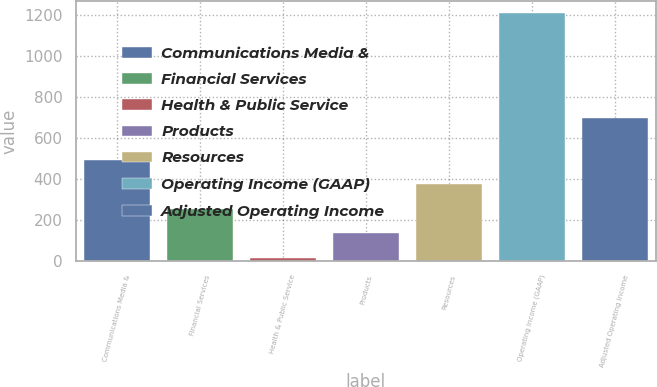Convert chart to OTSL. <chart><loc_0><loc_0><loc_500><loc_500><bar_chart><fcel>Communications Media &<fcel>Financial Services<fcel>Health & Public Service<fcel>Products<fcel>Resources<fcel>Operating Income (GAAP)<fcel>Adjusted Operating Income<nl><fcel>493.4<fcel>255.2<fcel>17<fcel>136.1<fcel>374.3<fcel>1208<fcel>699<nl></chart> 